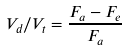Convert formula to latex. <formula><loc_0><loc_0><loc_500><loc_500>V _ { d } / V _ { t } = \frac { F _ { a } - F _ { e } } { F _ { a } }</formula> 